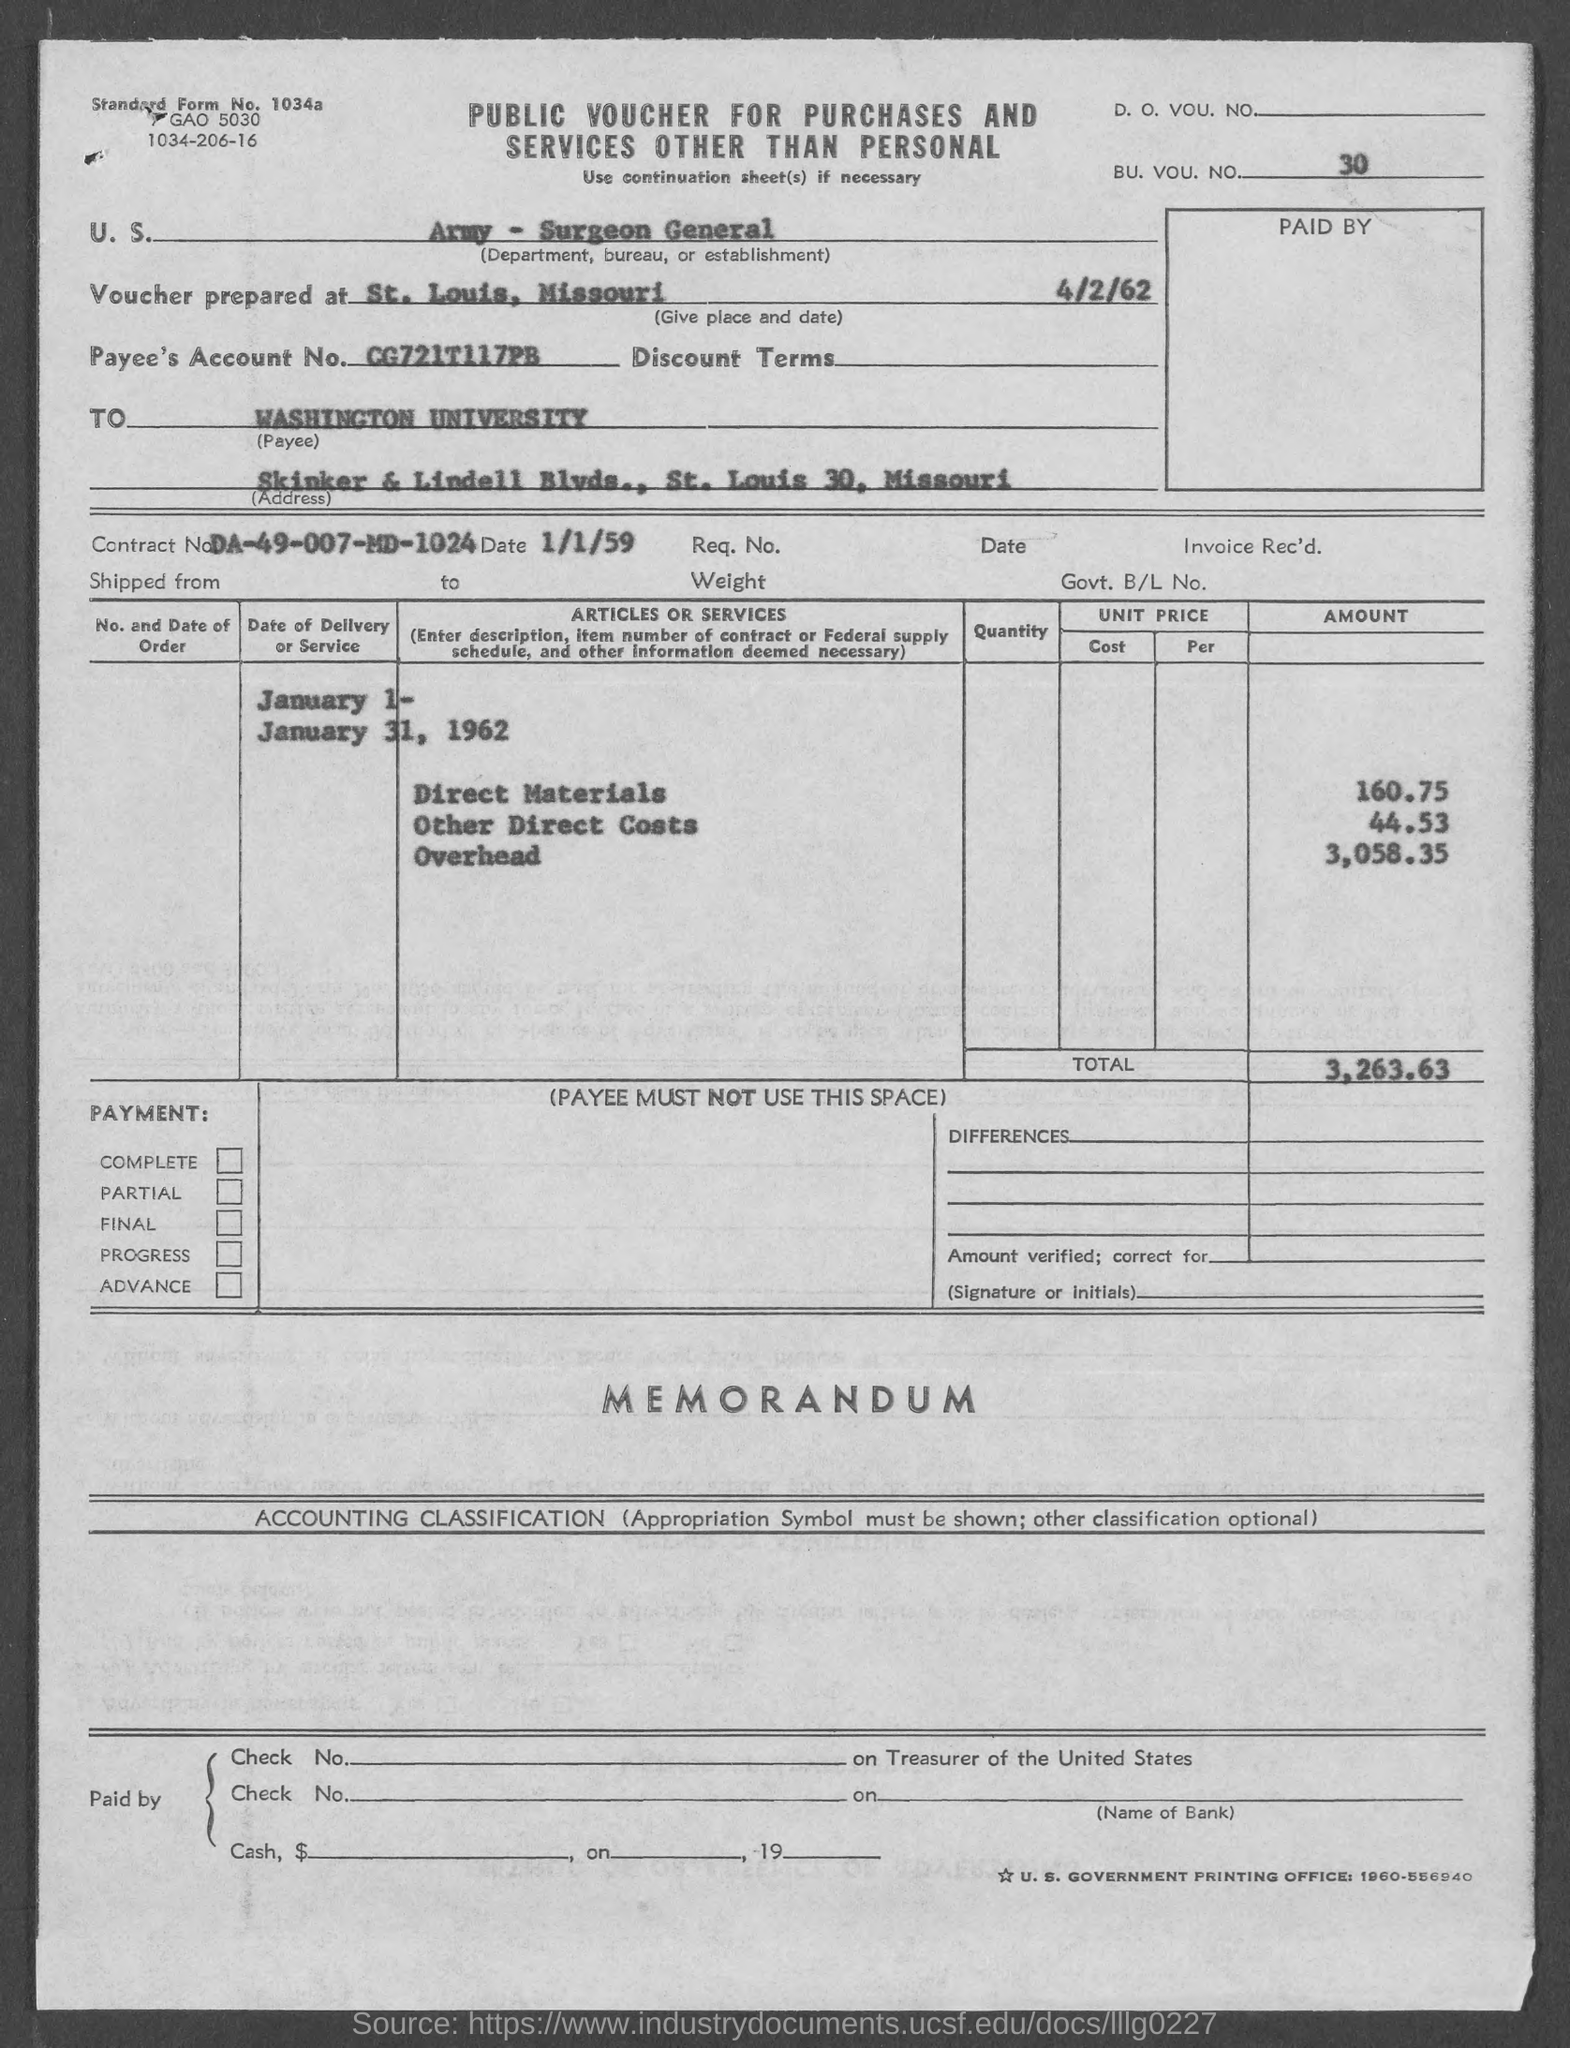What is the Standard Form No. given in the voucher?
Keep it short and to the point. 1034a. What is the BU. VOU. NO. mentioned in the voucher?
Keep it short and to the point. 30. In which place & date is the voucher prepared?
Make the answer very short. St. Louis, Missouri     4/2/62. What is the Payee's Account No. given in the voucher?
Your answer should be compact. CG721T117PB. What is the Contract No. given in the voucher?
Provide a short and direct response. DA-49-007-MD-1024. What is the total amount mentioned in the voucher?
Give a very brief answer. 3,263.63. 